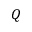Convert formula to latex. <formula><loc_0><loc_0><loc_500><loc_500>Q</formula> 